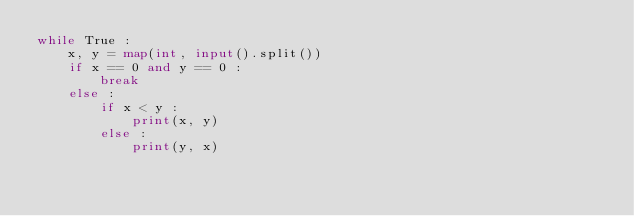<code> <loc_0><loc_0><loc_500><loc_500><_Python_>while True :
    x, y = map(int, input().split())
    if x == 0 and y == 0 :
        break
    else :
        if x < y :
            print(x, y)
        else :
            print(y, x)
    

</code> 